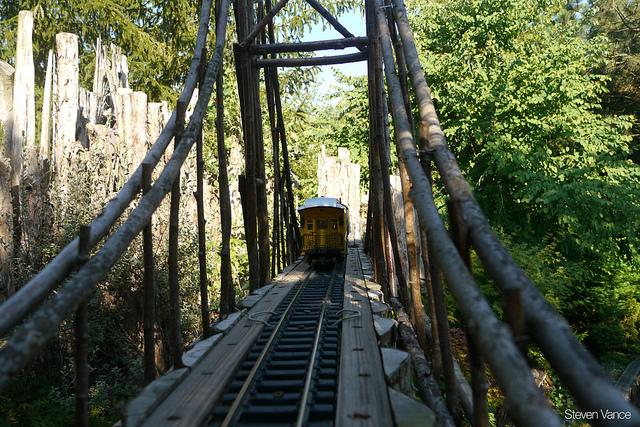What is the train coming over?
Write a very short answer. Bridge. What is the weather like?
Be succinct. Sunny. Is there more than one train?
Short answer required. No. 